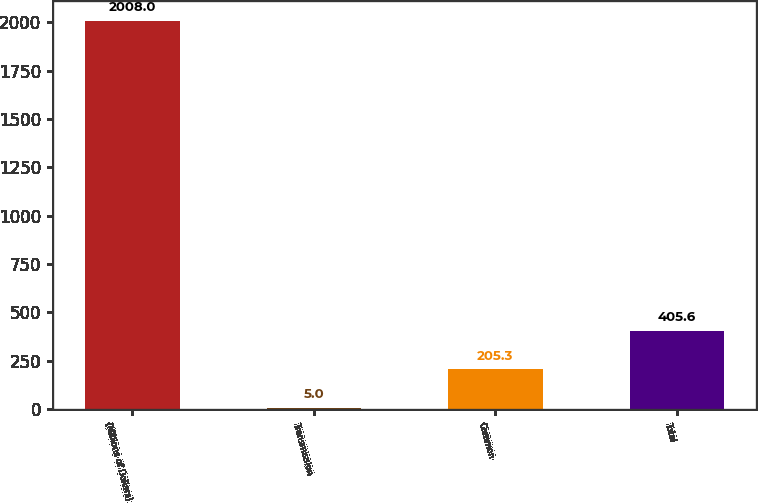Convert chart. <chart><loc_0><loc_0><loc_500><loc_500><bar_chart><fcel>(Millions of Dollars)<fcel>Transmission<fcel>Common<fcel>Total<nl><fcel>2008<fcel>5<fcel>205.3<fcel>405.6<nl></chart> 